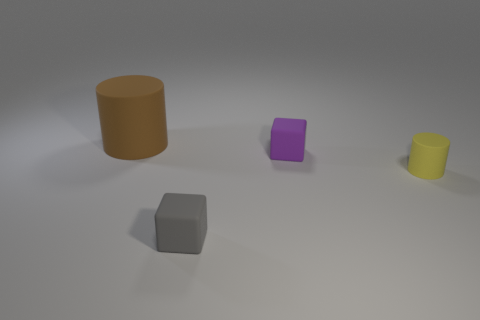How many small yellow rubber things are the same shape as the brown thing?
Ensure brevity in your answer.  1. Do the gray cube and the small cube on the right side of the tiny gray object have the same material?
Provide a succinct answer. Yes. There is a yellow cylinder that is the same size as the gray object; what material is it?
Give a very brief answer. Rubber. Are there any yellow cylinders of the same size as the yellow object?
Provide a succinct answer. No. The purple thing that is the same size as the gray thing is what shape?
Give a very brief answer. Cube. How many other objects are the same color as the tiny rubber cylinder?
Ensure brevity in your answer.  0. There is a object that is on the left side of the purple rubber cube and on the right side of the brown thing; what shape is it?
Your answer should be very brief. Cube. Is there a yellow rubber cylinder left of the cylinder on the right side of the matte cylinder behind the small cylinder?
Offer a terse response. No. How many other objects are the same material as the big brown thing?
Ensure brevity in your answer.  3. What number of tiny purple matte objects are there?
Give a very brief answer. 1. 